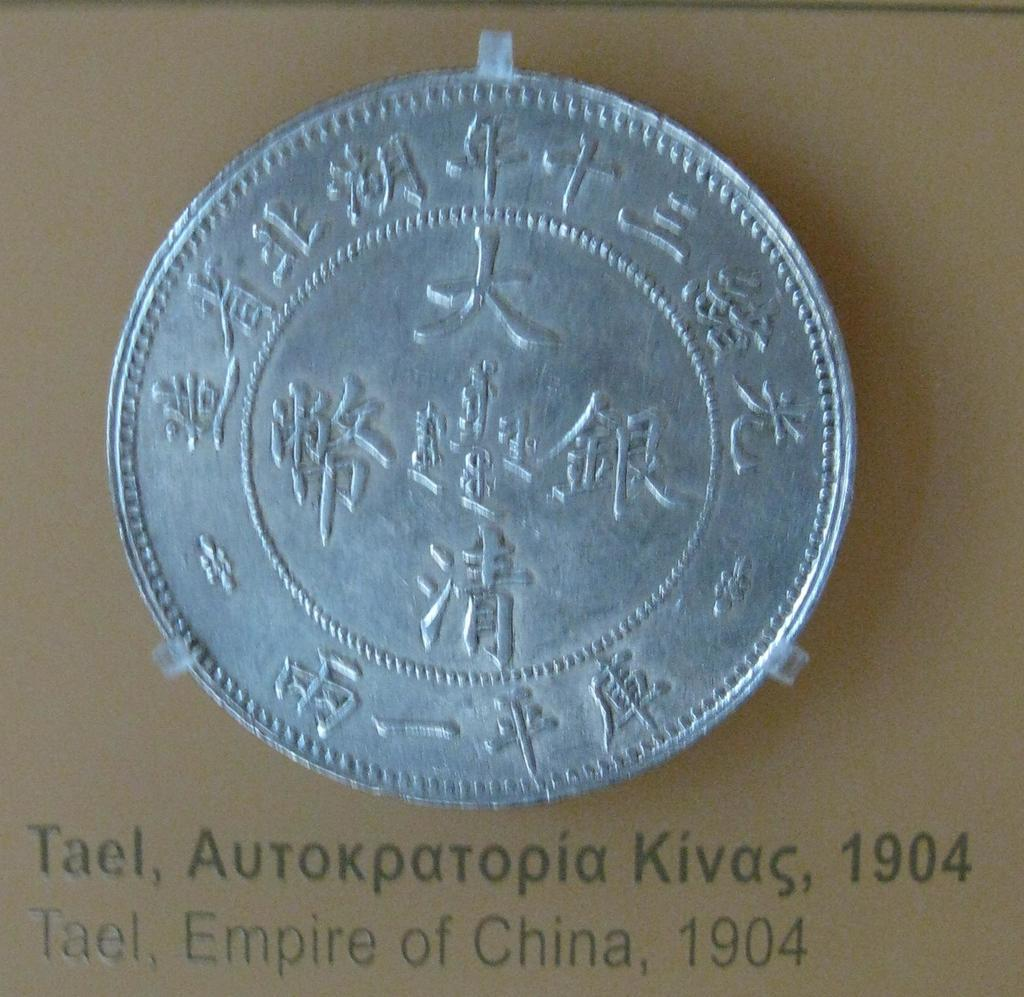Provide a one-sentence caption for the provided image. A silver coin with a year and the Empire of China written underneath it. 